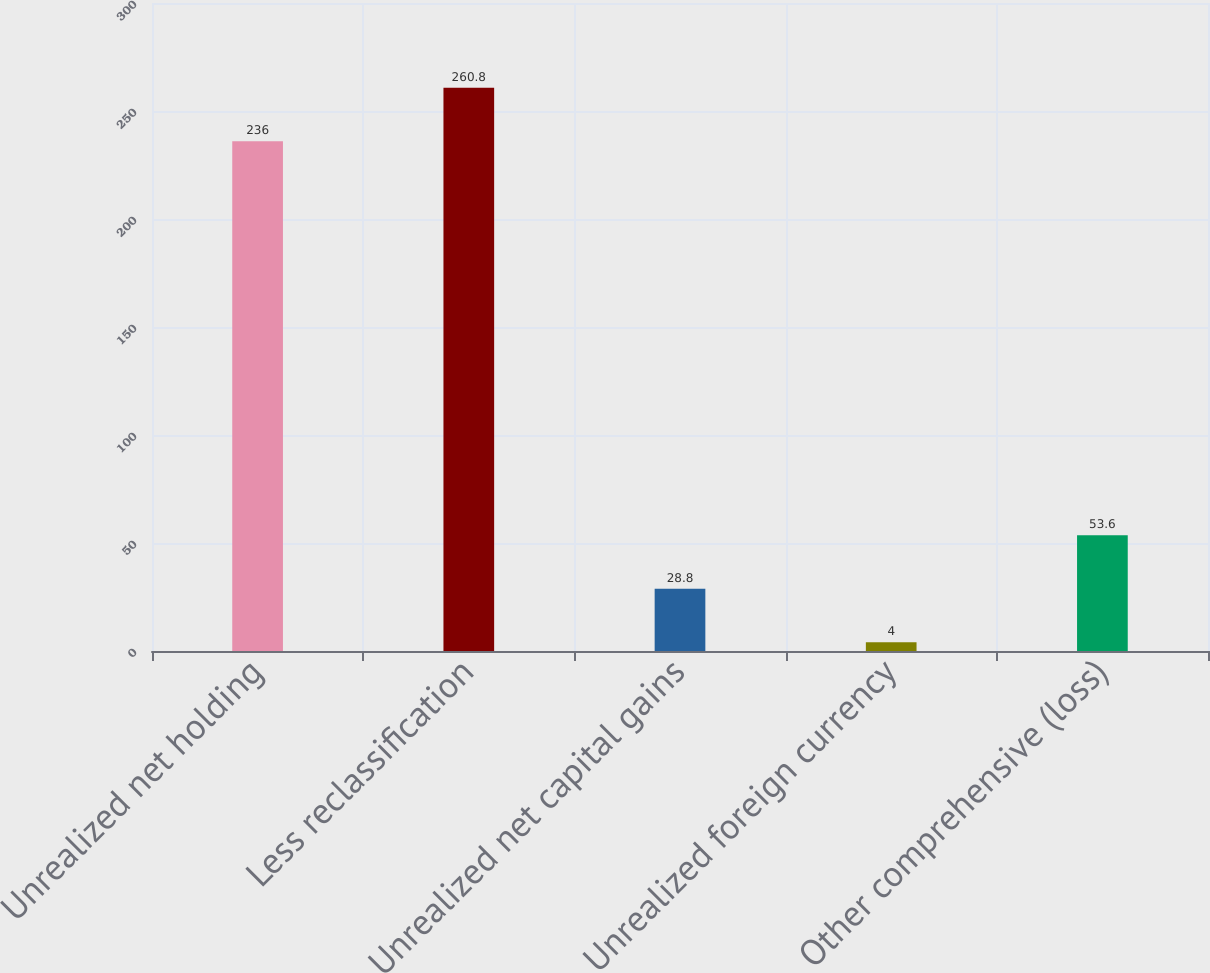Convert chart. <chart><loc_0><loc_0><loc_500><loc_500><bar_chart><fcel>Unrealized net holding<fcel>Less reclassification<fcel>Unrealized net capital gains<fcel>Unrealized foreign currency<fcel>Other comprehensive (loss)<nl><fcel>236<fcel>260.8<fcel>28.8<fcel>4<fcel>53.6<nl></chart> 